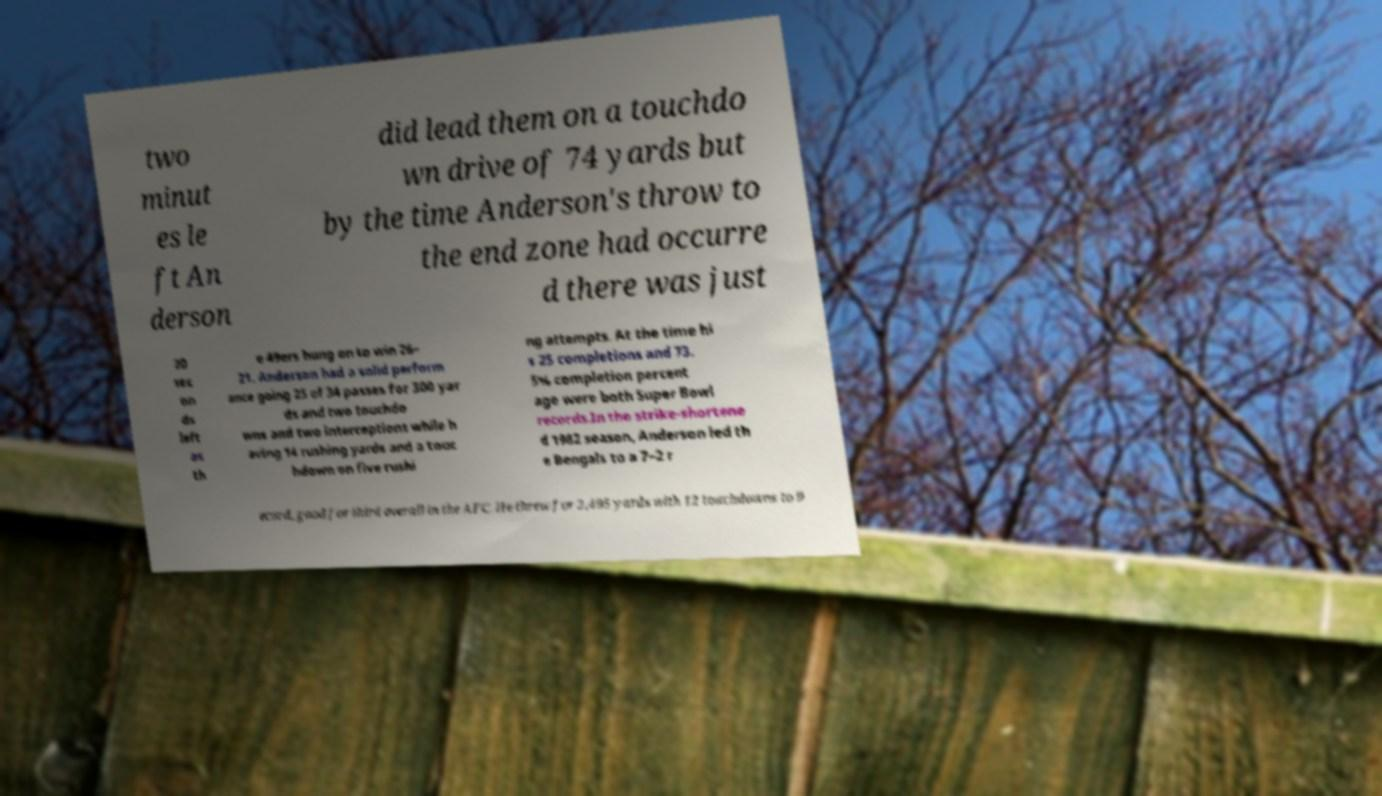Could you extract and type out the text from this image? two minut es le ft An derson did lead them on a touchdo wn drive of 74 yards but by the time Anderson's throw to the end zone had occurre d there was just 20 sec on ds left as th e 49ers hung on to win 26– 21. Anderson had a solid perform ance going 25 of 34 passes for 300 yar ds and two touchdo wns and two interceptions while h aving 14 rushing yards and a touc hdown on five rushi ng attempts. At the time hi s 25 completions and 73. 5% completion percent age were both Super Bowl records.In the strike-shortene d 1982 season, Anderson led th e Bengals to a 7–2 r ecord, good for third overall in the AFC. He threw for 2,495 yards with 12 touchdowns to 9 